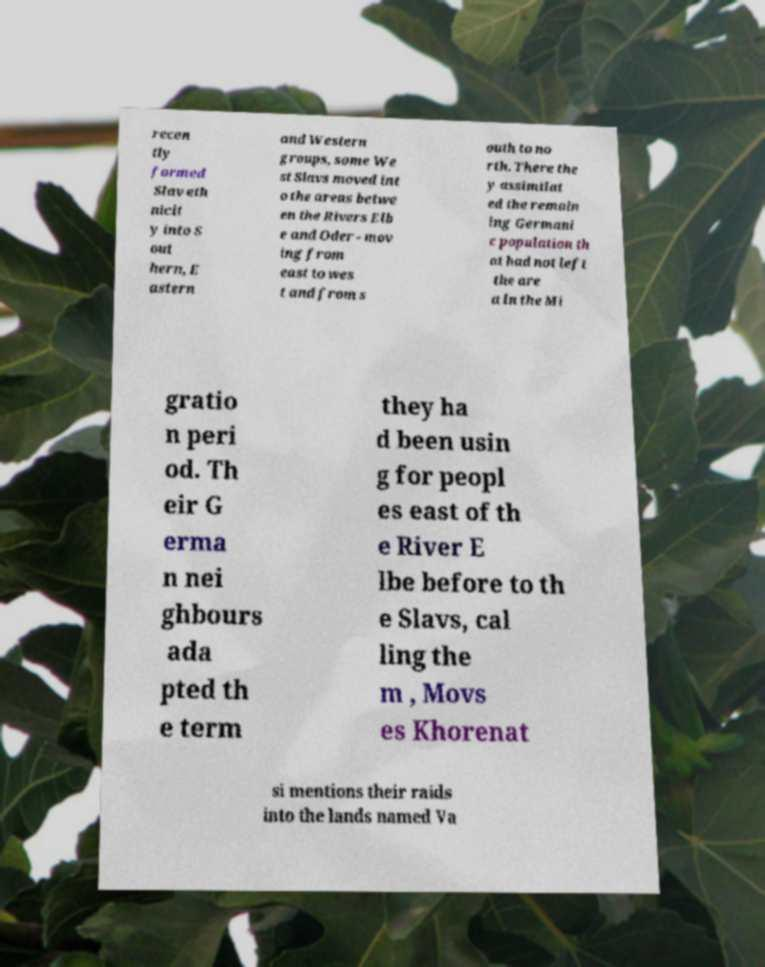What messages or text are displayed in this image? I need them in a readable, typed format. recen tly formed Slav eth nicit y into S out hern, E astern and Western groups, some We st Slavs moved int o the areas betwe en the Rivers Elb e and Oder - mov ing from east to wes t and from s outh to no rth. There the y assimilat ed the remain ing Germani c population th at had not left the are a in the Mi gratio n peri od. Th eir G erma n nei ghbours ada pted th e term they ha d been usin g for peopl es east of th e River E lbe before to th e Slavs, cal ling the m , Movs es Khorenat si mentions their raids into the lands named Va 